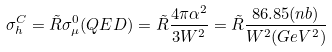Convert formula to latex. <formula><loc_0><loc_0><loc_500><loc_500>\sigma _ { h } ^ { C } = \tilde { R } \sigma _ { \mu } ^ { 0 } ( Q E D ) = \tilde { R } \frac { 4 \pi \alpha ^ { 2 } } { 3 W ^ { 2 } } = \tilde { R } \frac { 8 6 . 8 5 ( n b ) } { W ^ { 2 } ( G e V ^ { 2 } ) }</formula> 